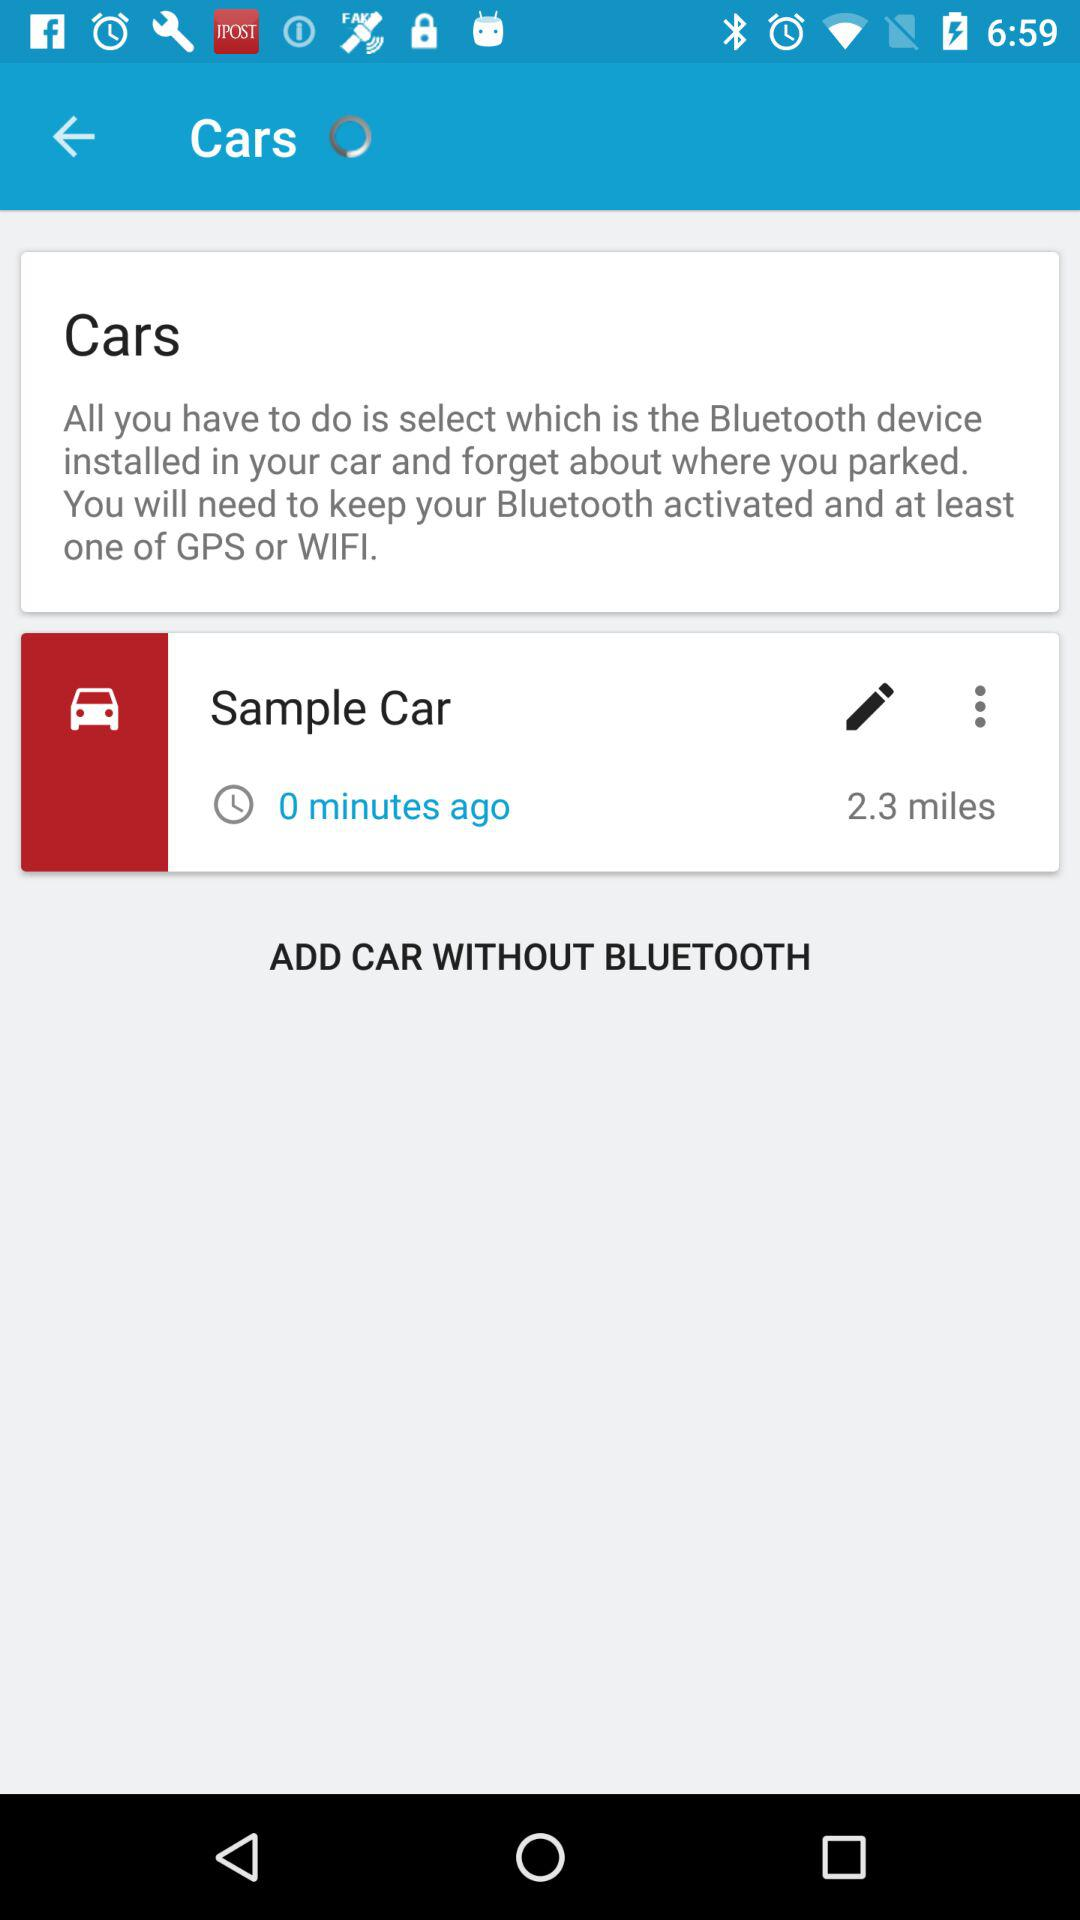How many miles to travel? You have to travel 2.3 miles. 